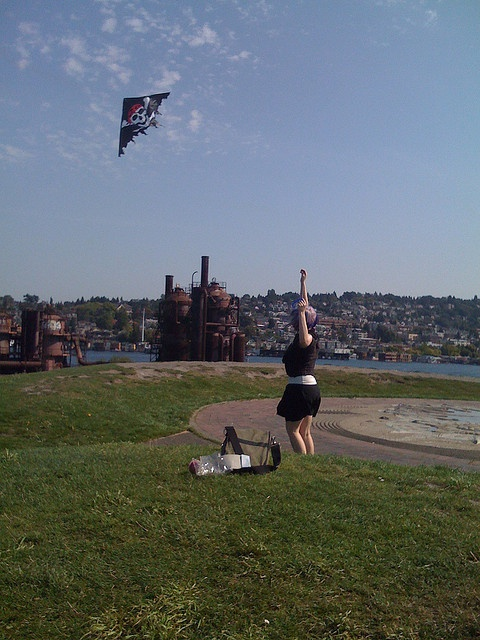Describe the objects in this image and their specific colors. I can see people in gray, black, and maroon tones, handbag in gray, black, and darkgray tones, and kite in gray, black, and navy tones in this image. 